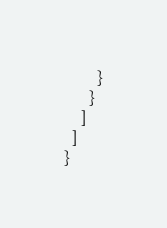Convert code to text. <code><loc_0><loc_0><loc_500><loc_500><_JavaScript_>        }
      }
    ]
  ]
}
</code> 